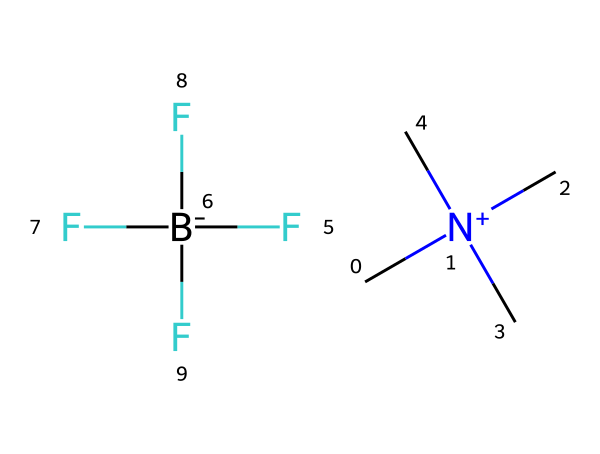what type of ions are present in this ionic liquid? The structure contains a quaternary ammonium cation (C[N+](C)(C)C) and a tetrafluoroborate anion (F[B-](F)(F)F).
Answer: quaternary ammonium and tetrafluoroborate how many carbon atoms are there in the cation part of this ionic liquid? The cation part is represented as C[N+](C)(C)C, which contains four carbon atoms directly attached to the nitrogen atom.
Answer: four what is the charge of the anion in this ionic liquid? The anion in this structure is indicated by the SMILES representation as F[B-](F)(F)F, showing it is negatively charged (B-).
Answer: negative what is the primary functional group in the cation of this ionic liquid? The cation features a quaternary ammonium group, which is characterized by the nitrogen atom bonded to four carbon groups.
Answer: quaternary ammonium why might ionic liquids like this one be used in anti-fogging treatments? Ionic liquids typically exhibit low volatility and high surface activity, potentially creating a barrier that prevents condensation on surfaces such as hockey visors.
Answer: low volatility and high surface activity how many fluorine atoms are present in the anion of this ionic liquid? The anion is represented as F[B-](F)(F)F, which has three fluorine atoms directly bonded to the boron atom.
Answer: three 